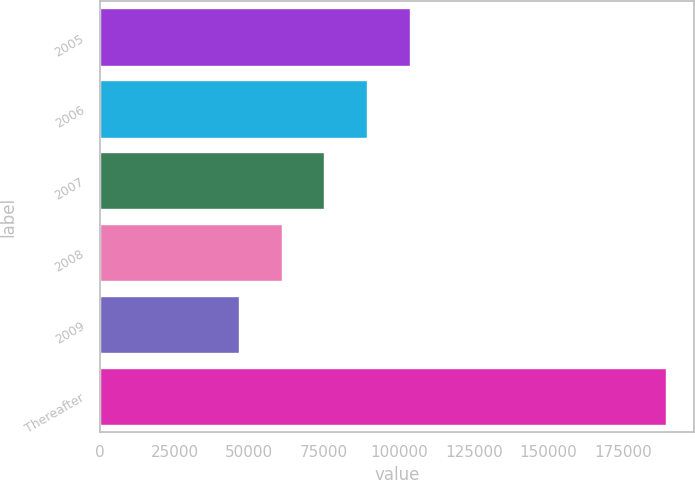<chart> <loc_0><loc_0><loc_500><loc_500><bar_chart><fcel>2005<fcel>2006<fcel>2007<fcel>2008<fcel>2009<fcel>Thereafter<nl><fcel>103521<fcel>89257.1<fcel>74993.4<fcel>60729.7<fcel>46466<fcel>189103<nl></chart> 